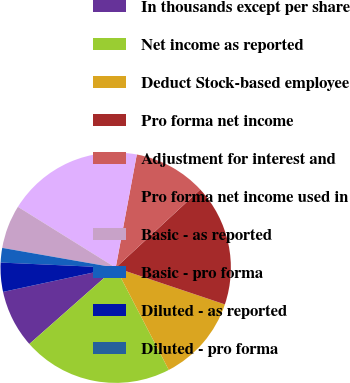<chart> <loc_0><loc_0><loc_500><loc_500><pie_chart><fcel>In thousands except per share<fcel>Net income as reported<fcel>Deduct Stock-based employee<fcel>Pro forma net income<fcel>Adjustment for interest and<fcel>Pro forma net income used in<fcel>Basic - as reported<fcel>Basic - pro forma<fcel>Diluted - as reported<fcel>Diluted - pro forma<nl><fcel>8.15%<fcel>21.11%<fcel>12.22%<fcel>17.03%<fcel>10.19%<fcel>19.07%<fcel>6.11%<fcel>2.04%<fcel>4.08%<fcel>0.0%<nl></chart> 